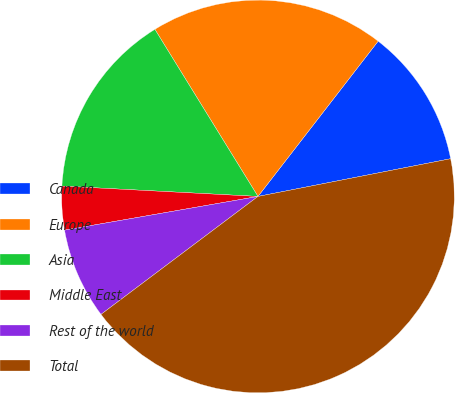<chart> <loc_0><loc_0><loc_500><loc_500><pie_chart><fcel>Canada<fcel>Europe<fcel>Asia<fcel>Middle East<fcel>Rest of the world<fcel>Total<nl><fcel>11.44%<fcel>19.28%<fcel>15.36%<fcel>3.59%<fcel>7.51%<fcel>42.82%<nl></chart> 